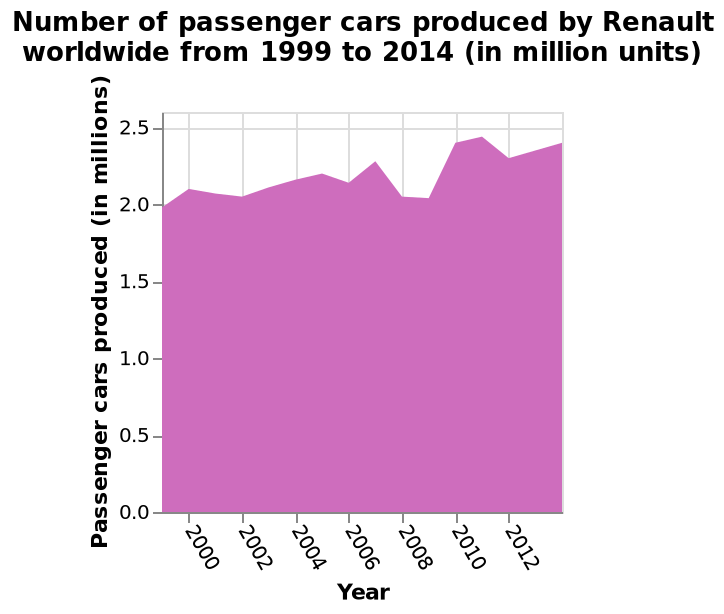<image>
Offer a thorough analysis of the image. The line is generally steady. There is a small sharp dip in 2008 that rises past its previous height in 2010 before again becoming steady. How many cars were produced in 2011? Around 2.5 million cars were produced in the year 2011. In what units is the number of passenger cars produced plotted on the y-axis?  The number of passenger cars produced is plotted on the y-axis in millions. Is the line generally unsteady? Is there a large gradual dip in 2008 that rises just below its previous height in 2010 before again becoming unsteady? No.The line is generally steady. There is a small sharp dip in 2008 that rises past its previous height in 2010 before again becoming steady. 